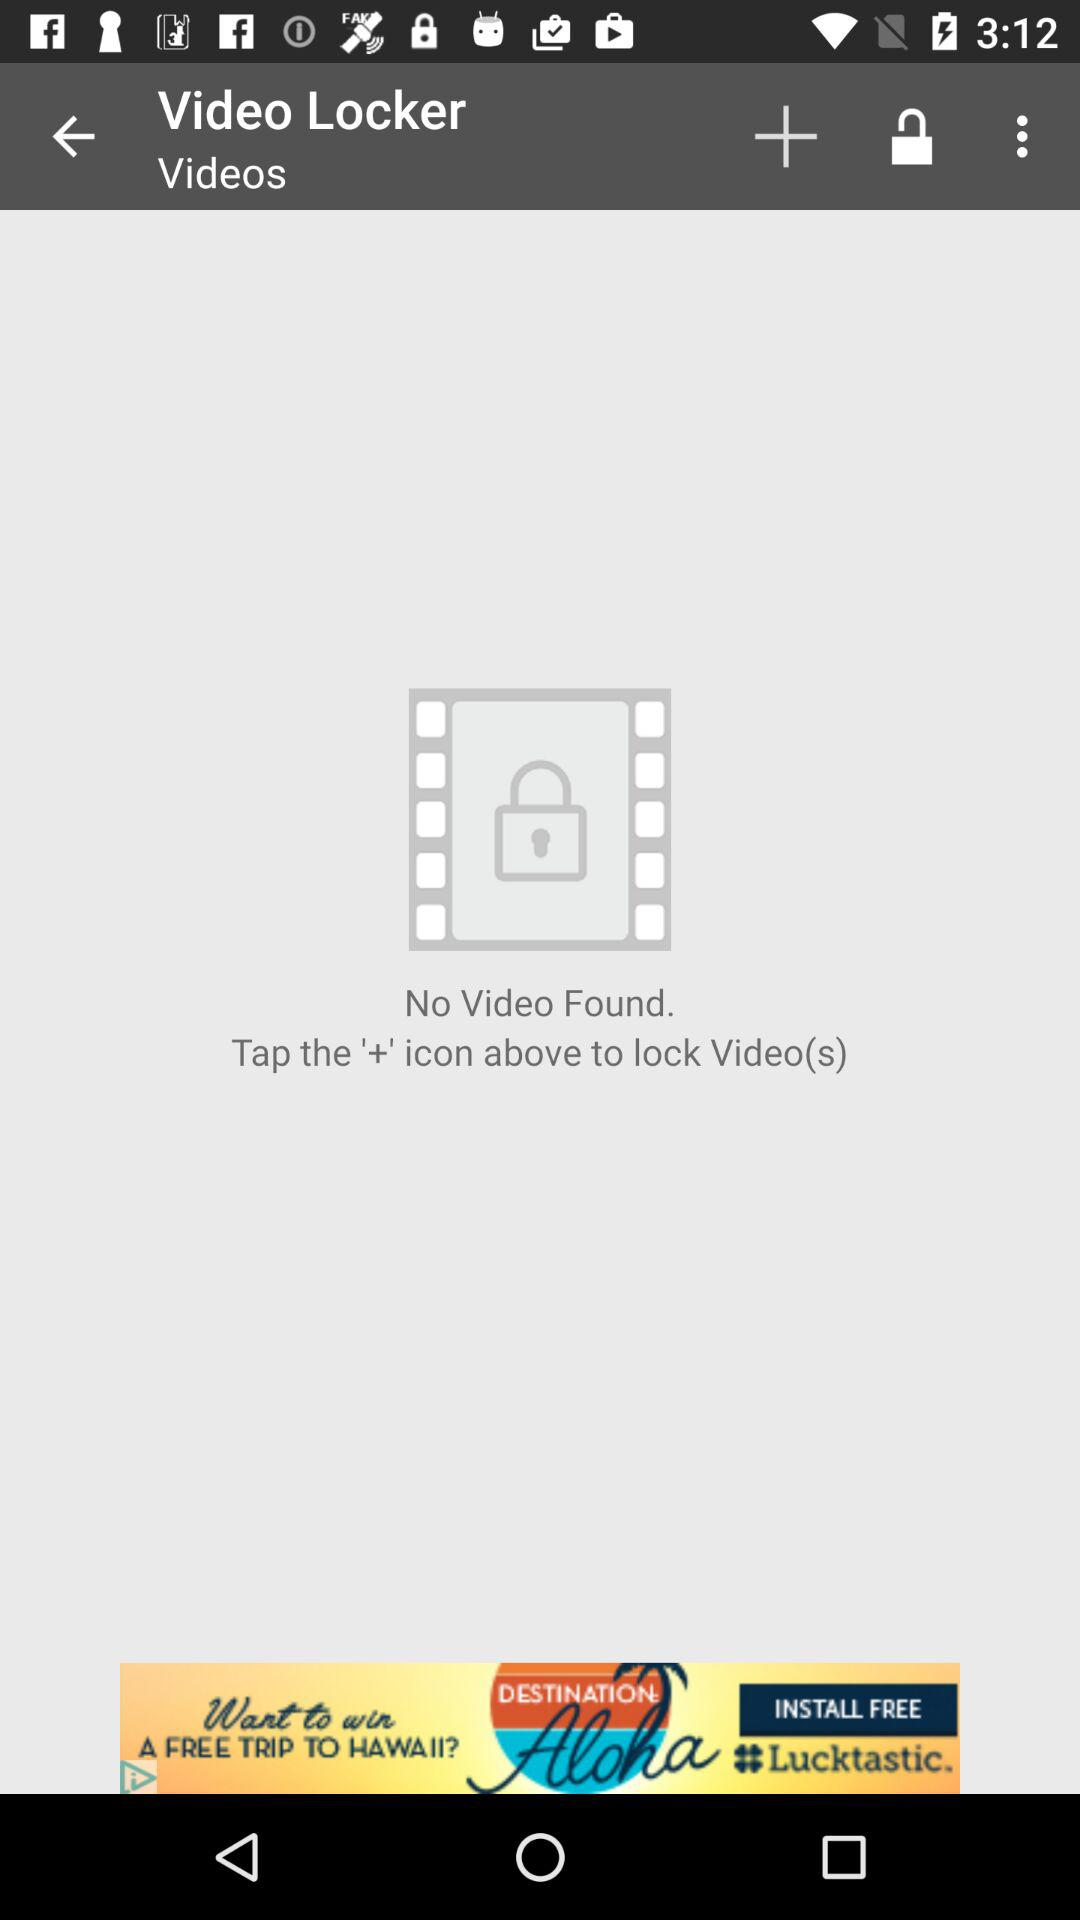How many videos were found? There was no video found. 